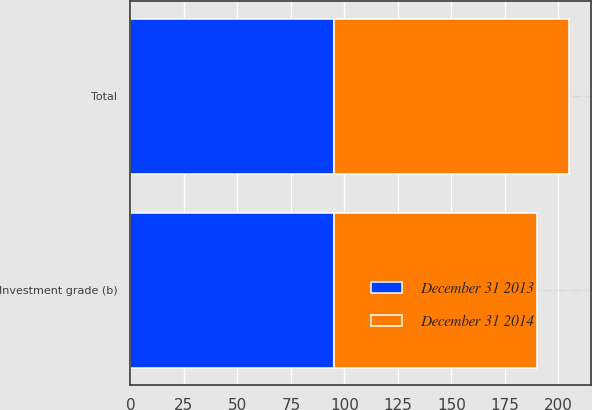Convert chart to OTSL. <chart><loc_0><loc_0><loc_500><loc_500><stacked_bar_chart><ecel><fcel>Investment grade (b)<fcel>Total<nl><fcel>December 31 2014<fcel>95<fcel>110<nl><fcel>December 31 2013<fcel>95<fcel>95<nl></chart> 